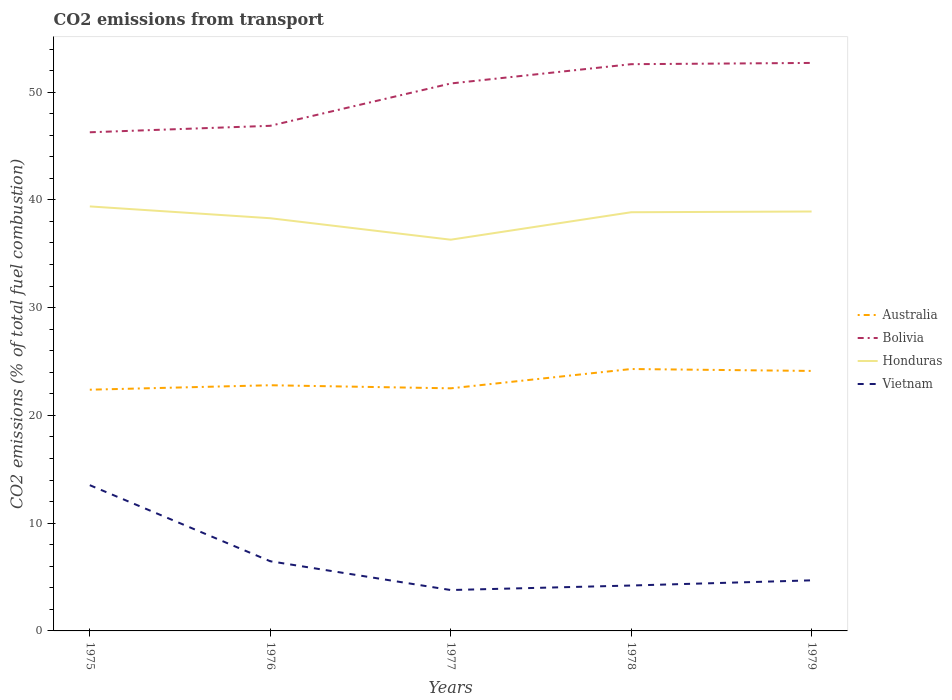Is the number of lines equal to the number of legend labels?
Your response must be concise. Yes. Across all years, what is the maximum total CO2 emitted in Australia?
Offer a terse response. 22.39. In which year was the total CO2 emitted in Bolivia maximum?
Your response must be concise. 1975. What is the total total CO2 emitted in Honduras in the graph?
Give a very brief answer. 0.47. What is the difference between the highest and the second highest total CO2 emitted in Vietnam?
Keep it short and to the point. 9.73. Is the total CO2 emitted in Vietnam strictly greater than the total CO2 emitted in Bolivia over the years?
Make the answer very short. Yes. How many lines are there?
Make the answer very short. 4. How many years are there in the graph?
Make the answer very short. 5. What is the difference between two consecutive major ticks on the Y-axis?
Ensure brevity in your answer.  10. Does the graph contain grids?
Keep it short and to the point. No. Where does the legend appear in the graph?
Your response must be concise. Center right. What is the title of the graph?
Give a very brief answer. CO2 emissions from transport. What is the label or title of the Y-axis?
Provide a succinct answer. CO2 emissions (% of total fuel combustion). What is the CO2 emissions (% of total fuel combustion) of Australia in 1975?
Provide a short and direct response. 22.39. What is the CO2 emissions (% of total fuel combustion) of Bolivia in 1975?
Your response must be concise. 46.27. What is the CO2 emissions (% of total fuel combustion) of Honduras in 1975?
Provide a succinct answer. 39.39. What is the CO2 emissions (% of total fuel combustion) in Vietnam in 1975?
Provide a succinct answer. 13.52. What is the CO2 emissions (% of total fuel combustion) in Australia in 1976?
Offer a very short reply. 22.8. What is the CO2 emissions (% of total fuel combustion) in Bolivia in 1976?
Your answer should be very brief. 46.88. What is the CO2 emissions (% of total fuel combustion) of Honduras in 1976?
Your answer should be compact. 38.3. What is the CO2 emissions (% of total fuel combustion) of Vietnam in 1976?
Offer a terse response. 6.47. What is the CO2 emissions (% of total fuel combustion) in Australia in 1977?
Offer a terse response. 22.51. What is the CO2 emissions (% of total fuel combustion) in Bolivia in 1977?
Your response must be concise. 50.8. What is the CO2 emissions (% of total fuel combustion) of Honduras in 1977?
Keep it short and to the point. 36.31. What is the CO2 emissions (% of total fuel combustion) in Vietnam in 1977?
Give a very brief answer. 3.79. What is the CO2 emissions (% of total fuel combustion) in Australia in 1978?
Offer a very short reply. 24.3. What is the CO2 emissions (% of total fuel combustion) of Bolivia in 1978?
Give a very brief answer. 52.59. What is the CO2 emissions (% of total fuel combustion) of Honduras in 1978?
Ensure brevity in your answer.  38.85. What is the CO2 emissions (% of total fuel combustion) of Vietnam in 1978?
Give a very brief answer. 4.21. What is the CO2 emissions (% of total fuel combustion) of Australia in 1979?
Ensure brevity in your answer.  24.13. What is the CO2 emissions (% of total fuel combustion) of Bolivia in 1979?
Offer a terse response. 52.71. What is the CO2 emissions (% of total fuel combustion) in Honduras in 1979?
Your answer should be very brief. 38.92. What is the CO2 emissions (% of total fuel combustion) of Vietnam in 1979?
Provide a succinct answer. 4.69. Across all years, what is the maximum CO2 emissions (% of total fuel combustion) of Australia?
Provide a short and direct response. 24.3. Across all years, what is the maximum CO2 emissions (% of total fuel combustion) in Bolivia?
Your answer should be very brief. 52.71. Across all years, what is the maximum CO2 emissions (% of total fuel combustion) of Honduras?
Provide a short and direct response. 39.39. Across all years, what is the maximum CO2 emissions (% of total fuel combustion) in Vietnam?
Provide a succinct answer. 13.52. Across all years, what is the minimum CO2 emissions (% of total fuel combustion) of Australia?
Ensure brevity in your answer.  22.39. Across all years, what is the minimum CO2 emissions (% of total fuel combustion) in Bolivia?
Keep it short and to the point. 46.27. Across all years, what is the minimum CO2 emissions (% of total fuel combustion) in Honduras?
Offer a terse response. 36.31. Across all years, what is the minimum CO2 emissions (% of total fuel combustion) of Vietnam?
Provide a succinct answer. 3.79. What is the total CO2 emissions (% of total fuel combustion) in Australia in the graph?
Ensure brevity in your answer.  116.13. What is the total CO2 emissions (% of total fuel combustion) of Bolivia in the graph?
Keep it short and to the point. 249.25. What is the total CO2 emissions (% of total fuel combustion) of Honduras in the graph?
Your response must be concise. 191.77. What is the total CO2 emissions (% of total fuel combustion) of Vietnam in the graph?
Give a very brief answer. 32.69. What is the difference between the CO2 emissions (% of total fuel combustion) of Australia in 1975 and that in 1976?
Provide a succinct answer. -0.41. What is the difference between the CO2 emissions (% of total fuel combustion) of Bolivia in 1975 and that in 1976?
Give a very brief answer. -0.6. What is the difference between the CO2 emissions (% of total fuel combustion) of Honduras in 1975 and that in 1976?
Ensure brevity in your answer.  1.1. What is the difference between the CO2 emissions (% of total fuel combustion) of Vietnam in 1975 and that in 1976?
Give a very brief answer. 7.06. What is the difference between the CO2 emissions (% of total fuel combustion) of Australia in 1975 and that in 1977?
Offer a very short reply. -0.13. What is the difference between the CO2 emissions (% of total fuel combustion) of Bolivia in 1975 and that in 1977?
Your answer should be very brief. -4.53. What is the difference between the CO2 emissions (% of total fuel combustion) of Honduras in 1975 and that in 1977?
Make the answer very short. 3.09. What is the difference between the CO2 emissions (% of total fuel combustion) in Vietnam in 1975 and that in 1977?
Your answer should be very brief. 9.73. What is the difference between the CO2 emissions (% of total fuel combustion) of Australia in 1975 and that in 1978?
Offer a terse response. -1.92. What is the difference between the CO2 emissions (% of total fuel combustion) in Bolivia in 1975 and that in 1978?
Offer a terse response. -6.32. What is the difference between the CO2 emissions (% of total fuel combustion) of Honduras in 1975 and that in 1978?
Your response must be concise. 0.54. What is the difference between the CO2 emissions (% of total fuel combustion) of Vietnam in 1975 and that in 1978?
Provide a succinct answer. 9.31. What is the difference between the CO2 emissions (% of total fuel combustion) in Australia in 1975 and that in 1979?
Ensure brevity in your answer.  -1.74. What is the difference between the CO2 emissions (% of total fuel combustion) of Bolivia in 1975 and that in 1979?
Provide a short and direct response. -6.44. What is the difference between the CO2 emissions (% of total fuel combustion) in Honduras in 1975 and that in 1979?
Provide a succinct answer. 0.47. What is the difference between the CO2 emissions (% of total fuel combustion) of Vietnam in 1975 and that in 1979?
Provide a succinct answer. 8.83. What is the difference between the CO2 emissions (% of total fuel combustion) of Australia in 1976 and that in 1977?
Ensure brevity in your answer.  0.29. What is the difference between the CO2 emissions (% of total fuel combustion) in Bolivia in 1976 and that in 1977?
Make the answer very short. -3.93. What is the difference between the CO2 emissions (% of total fuel combustion) in Honduras in 1976 and that in 1977?
Provide a short and direct response. 1.99. What is the difference between the CO2 emissions (% of total fuel combustion) in Vietnam in 1976 and that in 1977?
Offer a very short reply. 2.67. What is the difference between the CO2 emissions (% of total fuel combustion) of Australia in 1976 and that in 1978?
Give a very brief answer. -1.51. What is the difference between the CO2 emissions (% of total fuel combustion) of Bolivia in 1976 and that in 1978?
Provide a short and direct response. -5.72. What is the difference between the CO2 emissions (% of total fuel combustion) of Honduras in 1976 and that in 1978?
Offer a terse response. -0.56. What is the difference between the CO2 emissions (% of total fuel combustion) in Vietnam in 1976 and that in 1978?
Provide a short and direct response. 2.25. What is the difference between the CO2 emissions (% of total fuel combustion) in Australia in 1976 and that in 1979?
Provide a short and direct response. -1.33. What is the difference between the CO2 emissions (% of total fuel combustion) in Bolivia in 1976 and that in 1979?
Offer a very short reply. -5.83. What is the difference between the CO2 emissions (% of total fuel combustion) in Honduras in 1976 and that in 1979?
Offer a terse response. -0.62. What is the difference between the CO2 emissions (% of total fuel combustion) in Vietnam in 1976 and that in 1979?
Ensure brevity in your answer.  1.77. What is the difference between the CO2 emissions (% of total fuel combustion) of Australia in 1977 and that in 1978?
Offer a very short reply. -1.79. What is the difference between the CO2 emissions (% of total fuel combustion) of Bolivia in 1977 and that in 1978?
Provide a short and direct response. -1.79. What is the difference between the CO2 emissions (% of total fuel combustion) of Honduras in 1977 and that in 1978?
Provide a short and direct response. -2.55. What is the difference between the CO2 emissions (% of total fuel combustion) in Vietnam in 1977 and that in 1978?
Offer a very short reply. -0.42. What is the difference between the CO2 emissions (% of total fuel combustion) of Australia in 1977 and that in 1979?
Your answer should be compact. -1.61. What is the difference between the CO2 emissions (% of total fuel combustion) of Bolivia in 1977 and that in 1979?
Give a very brief answer. -1.91. What is the difference between the CO2 emissions (% of total fuel combustion) in Honduras in 1977 and that in 1979?
Your answer should be compact. -2.62. What is the difference between the CO2 emissions (% of total fuel combustion) of Vietnam in 1977 and that in 1979?
Make the answer very short. -0.9. What is the difference between the CO2 emissions (% of total fuel combustion) in Australia in 1978 and that in 1979?
Your response must be concise. 0.18. What is the difference between the CO2 emissions (% of total fuel combustion) in Bolivia in 1978 and that in 1979?
Your response must be concise. -0.12. What is the difference between the CO2 emissions (% of total fuel combustion) of Honduras in 1978 and that in 1979?
Provide a succinct answer. -0.07. What is the difference between the CO2 emissions (% of total fuel combustion) in Vietnam in 1978 and that in 1979?
Your answer should be compact. -0.48. What is the difference between the CO2 emissions (% of total fuel combustion) of Australia in 1975 and the CO2 emissions (% of total fuel combustion) of Bolivia in 1976?
Provide a succinct answer. -24.49. What is the difference between the CO2 emissions (% of total fuel combustion) of Australia in 1975 and the CO2 emissions (% of total fuel combustion) of Honduras in 1976?
Make the answer very short. -15.91. What is the difference between the CO2 emissions (% of total fuel combustion) of Australia in 1975 and the CO2 emissions (% of total fuel combustion) of Vietnam in 1976?
Your response must be concise. 15.92. What is the difference between the CO2 emissions (% of total fuel combustion) in Bolivia in 1975 and the CO2 emissions (% of total fuel combustion) in Honduras in 1976?
Provide a succinct answer. 7.98. What is the difference between the CO2 emissions (% of total fuel combustion) of Bolivia in 1975 and the CO2 emissions (% of total fuel combustion) of Vietnam in 1976?
Offer a terse response. 39.81. What is the difference between the CO2 emissions (% of total fuel combustion) of Honduras in 1975 and the CO2 emissions (% of total fuel combustion) of Vietnam in 1976?
Your answer should be very brief. 32.93. What is the difference between the CO2 emissions (% of total fuel combustion) of Australia in 1975 and the CO2 emissions (% of total fuel combustion) of Bolivia in 1977?
Give a very brief answer. -28.42. What is the difference between the CO2 emissions (% of total fuel combustion) in Australia in 1975 and the CO2 emissions (% of total fuel combustion) in Honduras in 1977?
Ensure brevity in your answer.  -13.92. What is the difference between the CO2 emissions (% of total fuel combustion) in Australia in 1975 and the CO2 emissions (% of total fuel combustion) in Vietnam in 1977?
Give a very brief answer. 18.59. What is the difference between the CO2 emissions (% of total fuel combustion) in Bolivia in 1975 and the CO2 emissions (% of total fuel combustion) in Honduras in 1977?
Provide a succinct answer. 9.97. What is the difference between the CO2 emissions (% of total fuel combustion) of Bolivia in 1975 and the CO2 emissions (% of total fuel combustion) of Vietnam in 1977?
Give a very brief answer. 42.48. What is the difference between the CO2 emissions (% of total fuel combustion) in Honduras in 1975 and the CO2 emissions (% of total fuel combustion) in Vietnam in 1977?
Keep it short and to the point. 35.6. What is the difference between the CO2 emissions (% of total fuel combustion) of Australia in 1975 and the CO2 emissions (% of total fuel combustion) of Bolivia in 1978?
Give a very brief answer. -30.21. What is the difference between the CO2 emissions (% of total fuel combustion) of Australia in 1975 and the CO2 emissions (% of total fuel combustion) of Honduras in 1978?
Offer a very short reply. -16.47. What is the difference between the CO2 emissions (% of total fuel combustion) in Australia in 1975 and the CO2 emissions (% of total fuel combustion) in Vietnam in 1978?
Ensure brevity in your answer.  18.17. What is the difference between the CO2 emissions (% of total fuel combustion) in Bolivia in 1975 and the CO2 emissions (% of total fuel combustion) in Honduras in 1978?
Your answer should be compact. 7.42. What is the difference between the CO2 emissions (% of total fuel combustion) in Bolivia in 1975 and the CO2 emissions (% of total fuel combustion) in Vietnam in 1978?
Give a very brief answer. 42.06. What is the difference between the CO2 emissions (% of total fuel combustion) of Honduras in 1975 and the CO2 emissions (% of total fuel combustion) of Vietnam in 1978?
Your answer should be very brief. 35.18. What is the difference between the CO2 emissions (% of total fuel combustion) of Australia in 1975 and the CO2 emissions (% of total fuel combustion) of Bolivia in 1979?
Your answer should be compact. -30.32. What is the difference between the CO2 emissions (% of total fuel combustion) of Australia in 1975 and the CO2 emissions (% of total fuel combustion) of Honduras in 1979?
Your answer should be very brief. -16.54. What is the difference between the CO2 emissions (% of total fuel combustion) in Australia in 1975 and the CO2 emissions (% of total fuel combustion) in Vietnam in 1979?
Ensure brevity in your answer.  17.69. What is the difference between the CO2 emissions (% of total fuel combustion) in Bolivia in 1975 and the CO2 emissions (% of total fuel combustion) in Honduras in 1979?
Provide a short and direct response. 7.35. What is the difference between the CO2 emissions (% of total fuel combustion) in Bolivia in 1975 and the CO2 emissions (% of total fuel combustion) in Vietnam in 1979?
Your response must be concise. 41.58. What is the difference between the CO2 emissions (% of total fuel combustion) in Honduras in 1975 and the CO2 emissions (% of total fuel combustion) in Vietnam in 1979?
Offer a very short reply. 34.7. What is the difference between the CO2 emissions (% of total fuel combustion) in Australia in 1976 and the CO2 emissions (% of total fuel combustion) in Bolivia in 1977?
Offer a terse response. -28. What is the difference between the CO2 emissions (% of total fuel combustion) in Australia in 1976 and the CO2 emissions (% of total fuel combustion) in Honduras in 1977?
Offer a terse response. -13.51. What is the difference between the CO2 emissions (% of total fuel combustion) of Australia in 1976 and the CO2 emissions (% of total fuel combustion) of Vietnam in 1977?
Provide a succinct answer. 19. What is the difference between the CO2 emissions (% of total fuel combustion) in Bolivia in 1976 and the CO2 emissions (% of total fuel combustion) in Honduras in 1977?
Ensure brevity in your answer.  10.57. What is the difference between the CO2 emissions (% of total fuel combustion) of Bolivia in 1976 and the CO2 emissions (% of total fuel combustion) of Vietnam in 1977?
Offer a very short reply. 43.08. What is the difference between the CO2 emissions (% of total fuel combustion) of Honduras in 1976 and the CO2 emissions (% of total fuel combustion) of Vietnam in 1977?
Offer a terse response. 34.5. What is the difference between the CO2 emissions (% of total fuel combustion) in Australia in 1976 and the CO2 emissions (% of total fuel combustion) in Bolivia in 1978?
Offer a terse response. -29.79. What is the difference between the CO2 emissions (% of total fuel combustion) of Australia in 1976 and the CO2 emissions (% of total fuel combustion) of Honduras in 1978?
Ensure brevity in your answer.  -16.05. What is the difference between the CO2 emissions (% of total fuel combustion) of Australia in 1976 and the CO2 emissions (% of total fuel combustion) of Vietnam in 1978?
Provide a succinct answer. 18.59. What is the difference between the CO2 emissions (% of total fuel combustion) in Bolivia in 1976 and the CO2 emissions (% of total fuel combustion) in Honduras in 1978?
Offer a terse response. 8.02. What is the difference between the CO2 emissions (% of total fuel combustion) in Bolivia in 1976 and the CO2 emissions (% of total fuel combustion) in Vietnam in 1978?
Your answer should be very brief. 42.66. What is the difference between the CO2 emissions (% of total fuel combustion) in Honduras in 1976 and the CO2 emissions (% of total fuel combustion) in Vietnam in 1978?
Your response must be concise. 34.08. What is the difference between the CO2 emissions (% of total fuel combustion) of Australia in 1976 and the CO2 emissions (% of total fuel combustion) of Bolivia in 1979?
Offer a terse response. -29.91. What is the difference between the CO2 emissions (% of total fuel combustion) of Australia in 1976 and the CO2 emissions (% of total fuel combustion) of Honduras in 1979?
Your response must be concise. -16.12. What is the difference between the CO2 emissions (% of total fuel combustion) of Australia in 1976 and the CO2 emissions (% of total fuel combustion) of Vietnam in 1979?
Ensure brevity in your answer.  18.1. What is the difference between the CO2 emissions (% of total fuel combustion) of Bolivia in 1976 and the CO2 emissions (% of total fuel combustion) of Honduras in 1979?
Your answer should be very brief. 7.95. What is the difference between the CO2 emissions (% of total fuel combustion) in Bolivia in 1976 and the CO2 emissions (% of total fuel combustion) in Vietnam in 1979?
Keep it short and to the point. 42.18. What is the difference between the CO2 emissions (% of total fuel combustion) of Honduras in 1976 and the CO2 emissions (% of total fuel combustion) of Vietnam in 1979?
Make the answer very short. 33.6. What is the difference between the CO2 emissions (% of total fuel combustion) of Australia in 1977 and the CO2 emissions (% of total fuel combustion) of Bolivia in 1978?
Your answer should be very brief. -30.08. What is the difference between the CO2 emissions (% of total fuel combustion) in Australia in 1977 and the CO2 emissions (% of total fuel combustion) in Honduras in 1978?
Provide a short and direct response. -16.34. What is the difference between the CO2 emissions (% of total fuel combustion) of Australia in 1977 and the CO2 emissions (% of total fuel combustion) of Vietnam in 1978?
Give a very brief answer. 18.3. What is the difference between the CO2 emissions (% of total fuel combustion) of Bolivia in 1977 and the CO2 emissions (% of total fuel combustion) of Honduras in 1978?
Your response must be concise. 11.95. What is the difference between the CO2 emissions (% of total fuel combustion) in Bolivia in 1977 and the CO2 emissions (% of total fuel combustion) in Vietnam in 1978?
Ensure brevity in your answer.  46.59. What is the difference between the CO2 emissions (% of total fuel combustion) of Honduras in 1977 and the CO2 emissions (% of total fuel combustion) of Vietnam in 1978?
Provide a short and direct response. 32.09. What is the difference between the CO2 emissions (% of total fuel combustion) of Australia in 1977 and the CO2 emissions (% of total fuel combustion) of Bolivia in 1979?
Provide a short and direct response. -30.2. What is the difference between the CO2 emissions (% of total fuel combustion) of Australia in 1977 and the CO2 emissions (% of total fuel combustion) of Honduras in 1979?
Give a very brief answer. -16.41. What is the difference between the CO2 emissions (% of total fuel combustion) of Australia in 1977 and the CO2 emissions (% of total fuel combustion) of Vietnam in 1979?
Make the answer very short. 17.82. What is the difference between the CO2 emissions (% of total fuel combustion) of Bolivia in 1977 and the CO2 emissions (% of total fuel combustion) of Honduras in 1979?
Offer a very short reply. 11.88. What is the difference between the CO2 emissions (% of total fuel combustion) in Bolivia in 1977 and the CO2 emissions (% of total fuel combustion) in Vietnam in 1979?
Ensure brevity in your answer.  46.11. What is the difference between the CO2 emissions (% of total fuel combustion) in Honduras in 1977 and the CO2 emissions (% of total fuel combustion) in Vietnam in 1979?
Your response must be concise. 31.61. What is the difference between the CO2 emissions (% of total fuel combustion) in Australia in 1978 and the CO2 emissions (% of total fuel combustion) in Bolivia in 1979?
Make the answer very short. -28.41. What is the difference between the CO2 emissions (% of total fuel combustion) in Australia in 1978 and the CO2 emissions (% of total fuel combustion) in Honduras in 1979?
Provide a short and direct response. -14.62. What is the difference between the CO2 emissions (% of total fuel combustion) of Australia in 1978 and the CO2 emissions (% of total fuel combustion) of Vietnam in 1979?
Your response must be concise. 19.61. What is the difference between the CO2 emissions (% of total fuel combustion) in Bolivia in 1978 and the CO2 emissions (% of total fuel combustion) in Honduras in 1979?
Your answer should be very brief. 13.67. What is the difference between the CO2 emissions (% of total fuel combustion) of Bolivia in 1978 and the CO2 emissions (% of total fuel combustion) of Vietnam in 1979?
Your response must be concise. 47.9. What is the difference between the CO2 emissions (% of total fuel combustion) in Honduras in 1978 and the CO2 emissions (% of total fuel combustion) in Vietnam in 1979?
Provide a short and direct response. 34.16. What is the average CO2 emissions (% of total fuel combustion) of Australia per year?
Your answer should be very brief. 23.23. What is the average CO2 emissions (% of total fuel combustion) of Bolivia per year?
Provide a short and direct response. 49.85. What is the average CO2 emissions (% of total fuel combustion) in Honduras per year?
Ensure brevity in your answer.  38.35. What is the average CO2 emissions (% of total fuel combustion) of Vietnam per year?
Offer a very short reply. 6.54. In the year 1975, what is the difference between the CO2 emissions (% of total fuel combustion) of Australia and CO2 emissions (% of total fuel combustion) of Bolivia?
Offer a terse response. -23.89. In the year 1975, what is the difference between the CO2 emissions (% of total fuel combustion) of Australia and CO2 emissions (% of total fuel combustion) of Honduras?
Provide a succinct answer. -17.01. In the year 1975, what is the difference between the CO2 emissions (% of total fuel combustion) in Australia and CO2 emissions (% of total fuel combustion) in Vietnam?
Provide a succinct answer. 8.86. In the year 1975, what is the difference between the CO2 emissions (% of total fuel combustion) of Bolivia and CO2 emissions (% of total fuel combustion) of Honduras?
Give a very brief answer. 6.88. In the year 1975, what is the difference between the CO2 emissions (% of total fuel combustion) in Bolivia and CO2 emissions (% of total fuel combustion) in Vietnam?
Provide a succinct answer. 32.75. In the year 1975, what is the difference between the CO2 emissions (% of total fuel combustion) of Honduras and CO2 emissions (% of total fuel combustion) of Vietnam?
Make the answer very short. 25.87. In the year 1976, what is the difference between the CO2 emissions (% of total fuel combustion) in Australia and CO2 emissions (% of total fuel combustion) in Bolivia?
Your answer should be compact. -24.08. In the year 1976, what is the difference between the CO2 emissions (% of total fuel combustion) in Australia and CO2 emissions (% of total fuel combustion) in Honduras?
Your response must be concise. -15.5. In the year 1976, what is the difference between the CO2 emissions (% of total fuel combustion) in Australia and CO2 emissions (% of total fuel combustion) in Vietnam?
Provide a short and direct response. 16.33. In the year 1976, what is the difference between the CO2 emissions (% of total fuel combustion) in Bolivia and CO2 emissions (% of total fuel combustion) in Honduras?
Provide a succinct answer. 8.58. In the year 1976, what is the difference between the CO2 emissions (% of total fuel combustion) of Bolivia and CO2 emissions (% of total fuel combustion) of Vietnam?
Give a very brief answer. 40.41. In the year 1976, what is the difference between the CO2 emissions (% of total fuel combustion) of Honduras and CO2 emissions (% of total fuel combustion) of Vietnam?
Your answer should be compact. 31.83. In the year 1977, what is the difference between the CO2 emissions (% of total fuel combustion) in Australia and CO2 emissions (% of total fuel combustion) in Bolivia?
Your answer should be very brief. -28.29. In the year 1977, what is the difference between the CO2 emissions (% of total fuel combustion) in Australia and CO2 emissions (% of total fuel combustion) in Honduras?
Keep it short and to the point. -13.79. In the year 1977, what is the difference between the CO2 emissions (% of total fuel combustion) in Australia and CO2 emissions (% of total fuel combustion) in Vietnam?
Keep it short and to the point. 18.72. In the year 1977, what is the difference between the CO2 emissions (% of total fuel combustion) of Bolivia and CO2 emissions (% of total fuel combustion) of Honduras?
Offer a terse response. 14.5. In the year 1977, what is the difference between the CO2 emissions (% of total fuel combustion) of Bolivia and CO2 emissions (% of total fuel combustion) of Vietnam?
Offer a very short reply. 47.01. In the year 1977, what is the difference between the CO2 emissions (% of total fuel combustion) of Honduras and CO2 emissions (% of total fuel combustion) of Vietnam?
Your answer should be very brief. 32.51. In the year 1978, what is the difference between the CO2 emissions (% of total fuel combustion) of Australia and CO2 emissions (% of total fuel combustion) of Bolivia?
Your answer should be compact. -28.29. In the year 1978, what is the difference between the CO2 emissions (% of total fuel combustion) in Australia and CO2 emissions (% of total fuel combustion) in Honduras?
Provide a succinct answer. -14.55. In the year 1978, what is the difference between the CO2 emissions (% of total fuel combustion) of Australia and CO2 emissions (% of total fuel combustion) of Vietnam?
Provide a short and direct response. 20.09. In the year 1978, what is the difference between the CO2 emissions (% of total fuel combustion) in Bolivia and CO2 emissions (% of total fuel combustion) in Honduras?
Provide a short and direct response. 13.74. In the year 1978, what is the difference between the CO2 emissions (% of total fuel combustion) in Bolivia and CO2 emissions (% of total fuel combustion) in Vietnam?
Provide a succinct answer. 48.38. In the year 1978, what is the difference between the CO2 emissions (% of total fuel combustion) of Honduras and CO2 emissions (% of total fuel combustion) of Vietnam?
Make the answer very short. 34.64. In the year 1979, what is the difference between the CO2 emissions (% of total fuel combustion) of Australia and CO2 emissions (% of total fuel combustion) of Bolivia?
Keep it short and to the point. -28.58. In the year 1979, what is the difference between the CO2 emissions (% of total fuel combustion) in Australia and CO2 emissions (% of total fuel combustion) in Honduras?
Offer a very short reply. -14.8. In the year 1979, what is the difference between the CO2 emissions (% of total fuel combustion) in Australia and CO2 emissions (% of total fuel combustion) in Vietnam?
Offer a very short reply. 19.43. In the year 1979, what is the difference between the CO2 emissions (% of total fuel combustion) of Bolivia and CO2 emissions (% of total fuel combustion) of Honduras?
Offer a terse response. 13.79. In the year 1979, what is the difference between the CO2 emissions (% of total fuel combustion) in Bolivia and CO2 emissions (% of total fuel combustion) in Vietnam?
Make the answer very short. 48.02. In the year 1979, what is the difference between the CO2 emissions (% of total fuel combustion) of Honduras and CO2 emissions (% of total fuel combustion) of Vietnam?
Ensure brevity in your answer.  34.23. What is the ratio of the CO2 emissions (% of total fuel combustion) in Australia in 1975 to that in 1976?
Ensure brevity in your answer.  0.98. What is the ratio of the CO2 emissions (% of total fuel combustion) in Bolivia in 1975 to that in 1976?
Keep it short and to the point. 0.99. What is the ratio of the CO2 emissions (% of total fuel combustion) of Honduras in 1975 to that in 1976?
Offer a terse response. 1.03. What is the ratio of the CO2 emissions (% of total fuel combustion) in Vietnam in 1975 to that in 1976?
Your answer should be compact. 2.09. What is the ratio of the CO2 emissions (% of total fuel combustion) of Bolivia in 1975 to that in 1977?
Offer a very short reply. 0.91. What is the ratio of the CO2 emissions (% of total fuel combustion) of Honduras in 1975 to that in 1977?
Make the answer very short. 1.09. What is the ratio of the CO2 emissions (% of total fuel combustion) of Vietnam in 1975 to that in 1977?
Offer a terse response. 3.56. What is the ratio of the CO2 emissions (% of total fuel combustion) in Australia in 1975 to that in 1978?
Your answer should be compact. 0.92. What is the ratio of the CO2 emissions (% of total fuel combustion) in Bolivia in 1975 to that in 1978?
Your answer should be compact. 0.88. What is the ratio of the CO2 emissions (% of total fuel combustion) in Honduras in 1975 to that in 1978?
Offer a terse response. 1.01. What is the ratio of the CO2 emissions (% of total fuel combustion) in Vietnam in 1975 to that in 1978?
Give a very brief answer. 3.21. What is the ratio of the CO2 emissions (% of total fuel combustion) of Australia in 1975 to that in 1979?
Your response must be concise. 0.93. What is the ratio of the CO2 emissions (% of total fuel combustion) of Bolivia in 1975 to that in 1979?
Make the answer very short. 0.88. What is the ratio of the CO2 emissions (% of total fuel combustion) of Honduras in 1975 to that in 1979?
Provide a short and direct response. 1.01. What is the ratio of the CO2 emissions (% of total fuel combustion) of Vietnam in 1975 to that in 1979?
Provide a succinct answer. 2.88. What is the ratio of the CO2 emissions (% of total fuel combustion) in Australia in 1976 to that in 1977?
Your answer should be compact. 1.01. What is the ratio of the CO2 emissions (% of total fuel combustion) of Bolivia in 1976 to that in 1977?
Offer a very short reply. 0.92. What is the ratio of the CO2 emissions (% of total fuel combustion) in Honduras in 1976 to that in 1977?
Your answer should be compact. 1.05. What is the ratio of the CO2 emissions (% of total fuel combustion) in Vietnam in 1976 to that in 1977?
Make the answer very short. 1.7. What is the ratio of the CO2 emissions (% of total fuel combustion) in Australia in 1976 to that in 1978?
Make the answer very short. 0.94. What is the ratio of the CO2 emissions (% of total fuel combustion) of Bolivia in 1976 to that in 1978?
Your answer should be compact. 0.89. What is the ratio of the CO2 emissions (% of total fuel combustion) in Honduras in 1976 to that in 1978?
Offer a very short reply. 0.99. What is the ratio of the CO2 emissions (% of total fuel combustion) of Vietnam in 1976 to that in 1978?
Ensure brevity in your answer.  1.53. What is the ratio of the CO2 emissions (% of total fuel combustion) of Australia in 1976 to that in 1979?
Your answer should be very brief. 0.94. What is the ratio of the CO2 emissions (% of total fuel combustion) in Bolivia in 1976 to that in 1979?
Your response must be concise. 0.89. What is the ratio of the CO2 emissions (% of total fuel combustion) in Vietnam in 1976 to that in 1979?
Ensure brevity in your answer.  1.38. What is the ratio of the CO2 emissions (% of total fuel combustion) of Australia in 1977 to that in 1978?
Your response must be concise. 0.93. What is the ratio of the CO2 emissions (% of total fuel combustion) in Bolivia in 1977 to that in 1978?
Keep it short and to the point. 0.97. What is the ratio of the CO2 emissions (% of total fuel combustion) of Honduras in 1977 to that in 1978?
Ensure brevity in your answer.  0.93. What is the ratio of the CO2 emissions (% of total fuel combustion) of Vietnam in 1977 to that in 1978?
Provide a succinct answer. 0.9. What is the ratio of the CO2 emissions (% of total fuel combustion) in Australia in 1977 to that in 1979?
Your response must be concise. 0.93. What is the ratio of the CO2 emissions (% of total fuel combustion) in Bolivia in 1977 to that in 1979?
Your response must be concise. 0.96. What is the ratio of the CO2 emissions (% of total fuel combustion) in Honduras in 1977 to that in 1979?
Offer a terse response. 0.93. What is the ratio of the CO2 emissions (% of total fuel combustion) of Vietnam in 1977 to that in 1979?
Give a very brief answer. 0.81. What is the ratio of the CO2 emissions (% of total fuel combustion) in Australia in 1978 to that in 1979?
Your response must be concise. 1.01. What is the ratio of the CO2 emissions (% of total fuel combustion) in Honduras in 1978 to that in 1979?
Your answer should be very brief. 1. What is the ratio of the CO2 emissions (% of total fuel combustion) of Vietnam in 1978 to that in 1979?
Provide a short and direct response. 0.9. What is the difference between the highest and the second highest CO2 emissions (% of total fuel combustion) of Australia?
Offer a very short reply. 0.18. What is the difference between the highest and the second highest CO2 emissions (% of total fuel combustion) in Bolivia?
Make the answer very short. 0.12. What is the difference between the highest and the second highest CO2 emissions (% of total fuel combustion) of Honduras?
Make the answer very short. 0.47. What is the difference between the highest and the second highest CO2 emissions (% of total fuel combustion) in Vietnam?
Provide a short and direct response. 7.06. What is the difference between the highest and the lowest CO2 emissions (% of total fuel combustion) in Australia?
Ensure brevity in your answer.  1.92. What is the difference between the highest and the lowest CO2 emissions (% of total fuel combustion) in Bolivia?
Your answer should be compact. 6.44. What is the difference between the highest and the lowest CO2 emissions (% of total fuel combustion) of Honduras?
Keep it short and to the point. 3.09. What is the difference between the highest and the lowest CO2 emissions (% of total fuel combustion) of Vietnam?
Give a very brief answer. 9.73. 